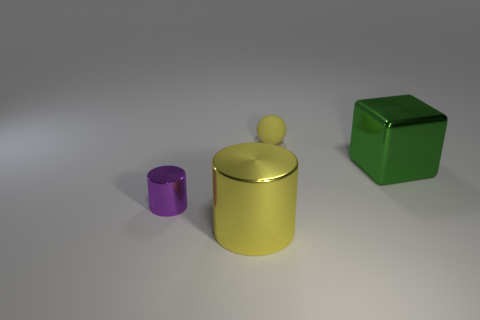What is the size of the other object that is the same shape as the purple thing?
Your answer should be very brief. Large. Are there fewer green metal cubes that are to the left of the purple metallic cylinder than large green cylinders?
Provide a short and direct response. No. How big is the thing on the left side of the large yellow object?
Offer a terse response. Small. The other thing that is the same shape as the purple thing is what color?
Your response must be concise. Yellow. How many big cubes have the same color as the matte sphere?
Your answer should be very brief. 0. Is there any other thing that is the same shape as the small matte object?
Offer a terse response. No. Is there a big metallic object in front of the big shiny thing that is left of the big metallic cube in front of the tiny yellow sphere?
Your response must be concise. No. How many large cylinders are made of the same material as the small purple cylinder?
Offer a terse response. 1. Is the size of the block that is in front of the matte ball the same as the yellow object behind the green thing?
Ensure brevity in your answer.  No. What color is the cylinder that is behind the yellow thing that is in front of the tiny thing that is in front of the yellow ball?
Make the answer very short. Purple. 